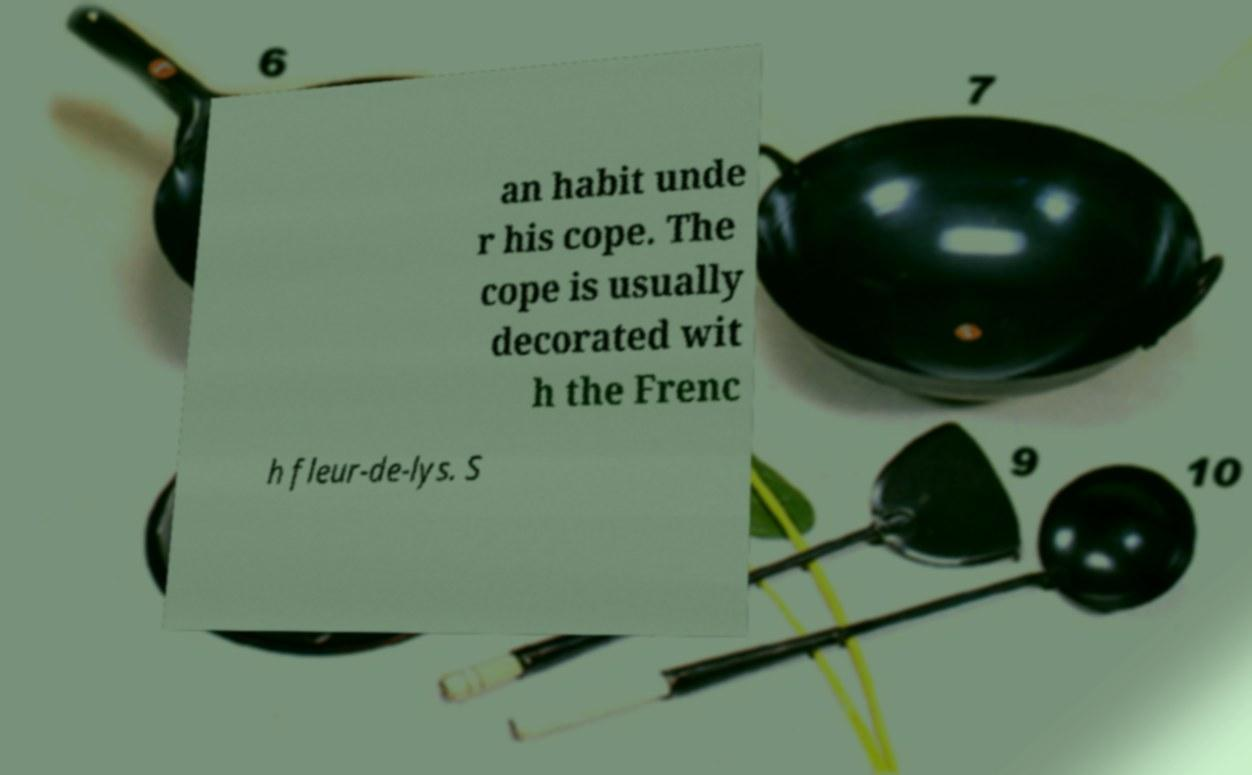For documentation purposes, I need the text within this image transcribed. Could you provide that? an habit unde r his cope. The cope is usually decorated wit h the Frenc h fleur-de-lys. S 